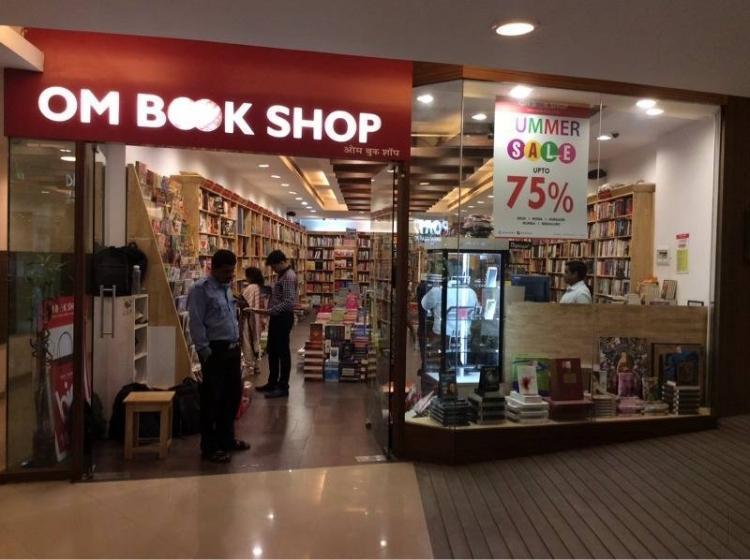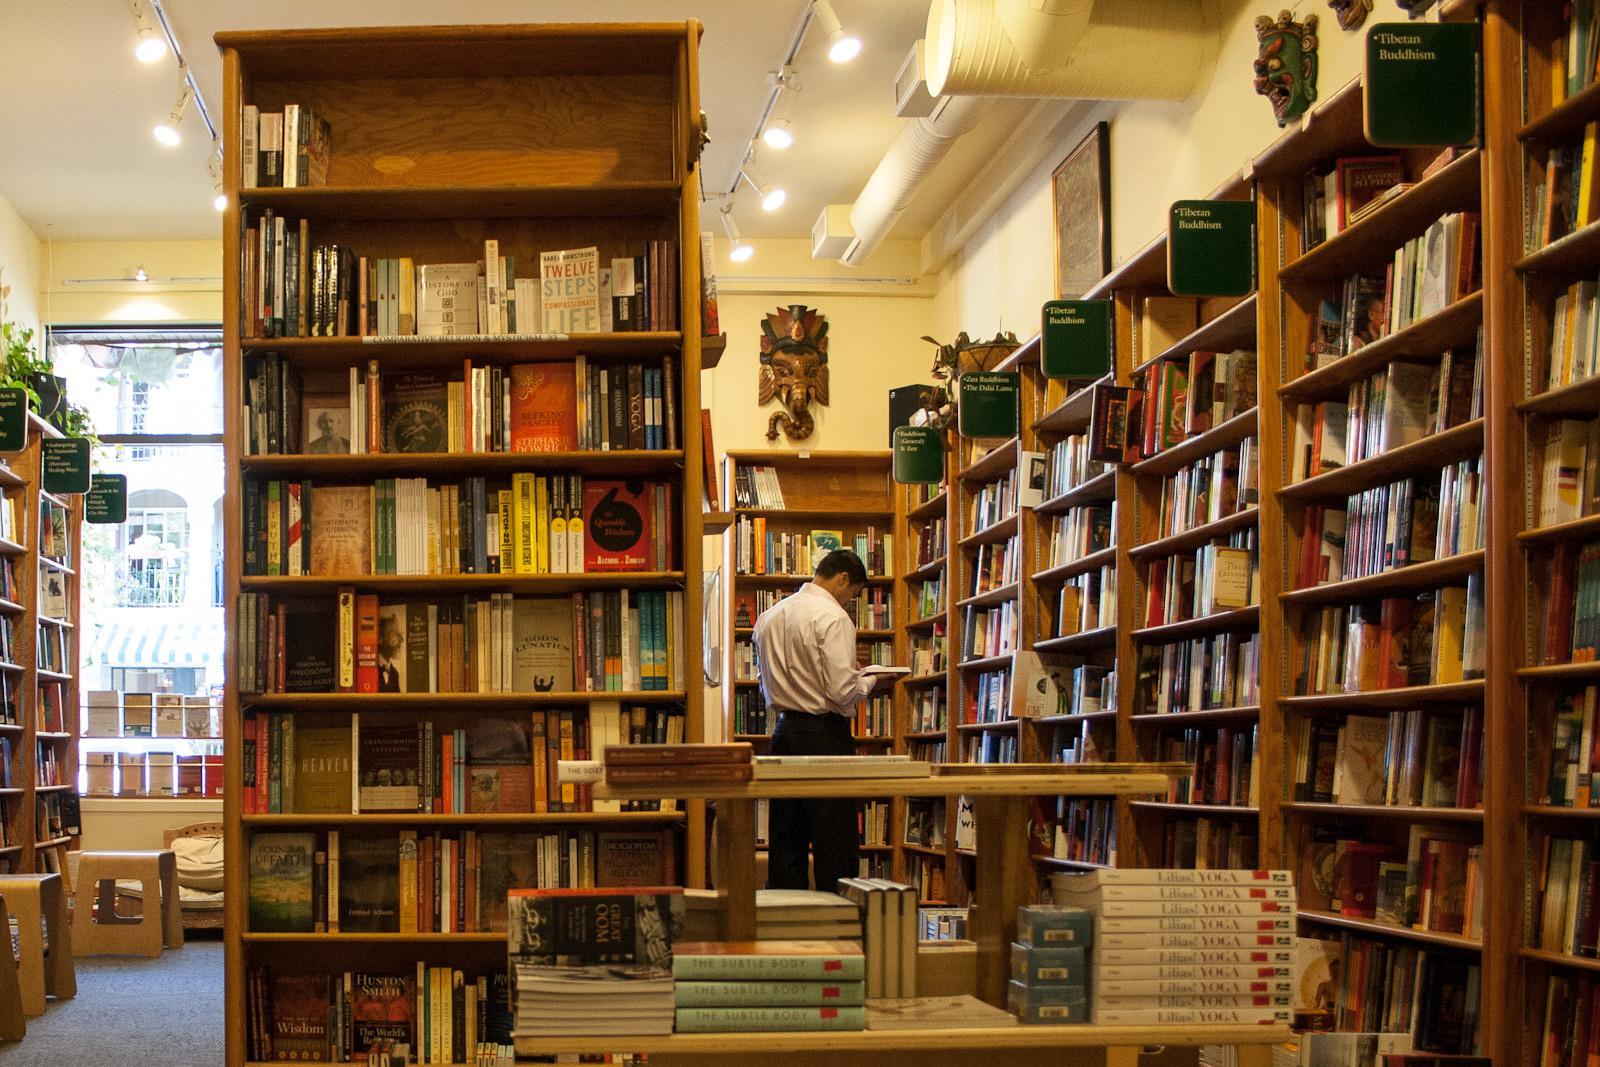The first image is the image on the left, the second image is the image on the right. Evaluate the accuracy of this statement regarding the images: "There is no human inside a store in the left image.". Is it true? Answer yes or no. No. The first image is the image on the left, the second image is the image on the right. Given the left and right images, does the statement "The signage for the store can only be seen in one of the images." hold true? Answer yes or no. Yes. 